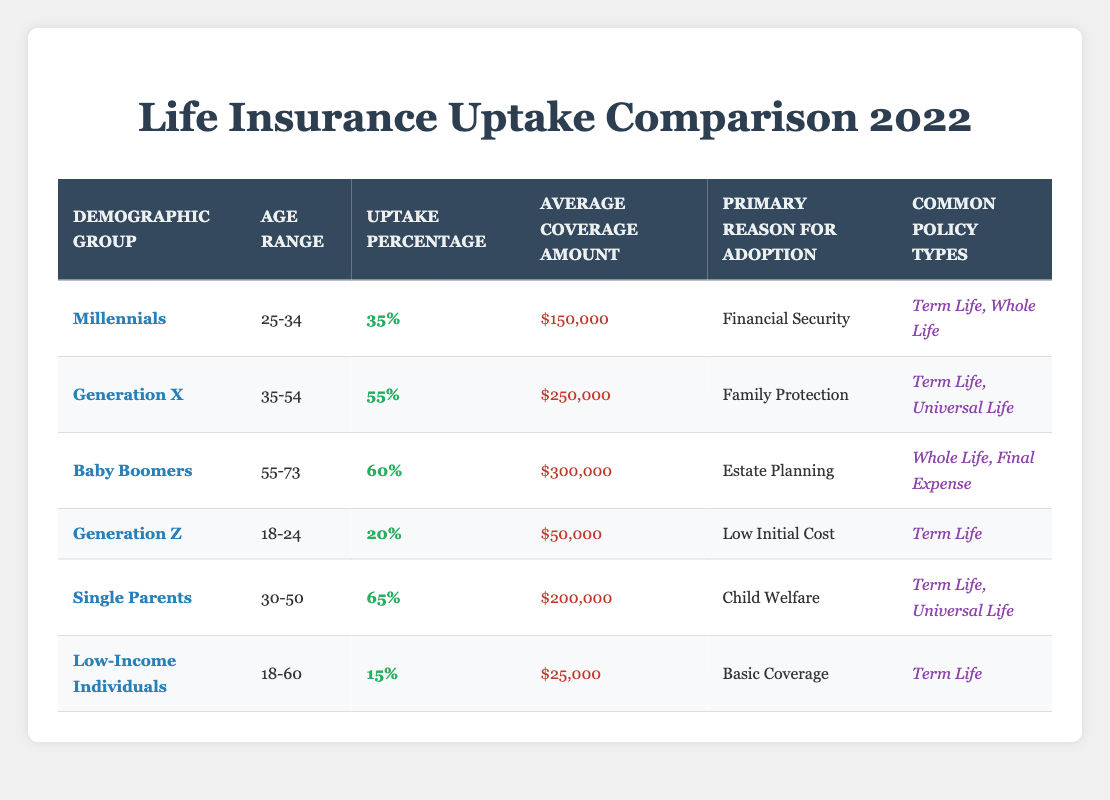What is the uptake percentage for Baby Boomers? According to the table, the uptake percentage for Baby Boomers is listed directly under the "Uptake Percentage" column, which states 60%.
Answer: 60% What is the average coverage amount for Single Parents? The table outlines that for Single Parents, the average coverage amount can be found in the "Average Coverage Amount" column, showing $200,000.
Answer: $200,000 Which demographic group has the highest uptake percentage, and what is the percentage? By examining the "Uptake Percentage" column, we see that Single Parents have the highest uptake percentage at 65%.
Answer: Single Parents, 65% Is the primary reason for adoption for Millennials "Financial Security"? The table provides the primary reason for adoption next to the Millennials demographic. It confirms that it is indeed "Financial Security."
Answer: Yes How does the average coverage amount for Low-Income Individuals compare to that of Generation Z? The average coverage amount for Low-Income Individuals is $25,000, whereas for Generation Z, it is $50,000. Thus, the average for Low-Income Individuals is less than that for Generation Z by $25,000.
Answer: $25,000 less What is the total uptake percentage for Millennials and Generation Z combined? To find the combined uptake percentage, we add the uptake percentages: Millennials have 35% and Generation Z has 20%. Thus, 35% + 20% = 55%.
Answer: 55% Which demographic group least values life insurance based on uptake percentage? Reviewing the "Uptake Percentage" column, we find that Low-Income Individuals, at 15%, have the lowest uptake percentage, indicating they least value life insurance.
Answer: Low-Income Individuals What percentage of Baby Boomers has chosen "Whole Life" as a common policy type? The table shows that Baby Boomers typically choose "Whole Life" among other types, but it does not specify a percentage for this. However, Whole Life is mentioned as one of their common policy types. Therefore, we cannot derive a specific percentage from the data available.
Answer: Not available in the table 